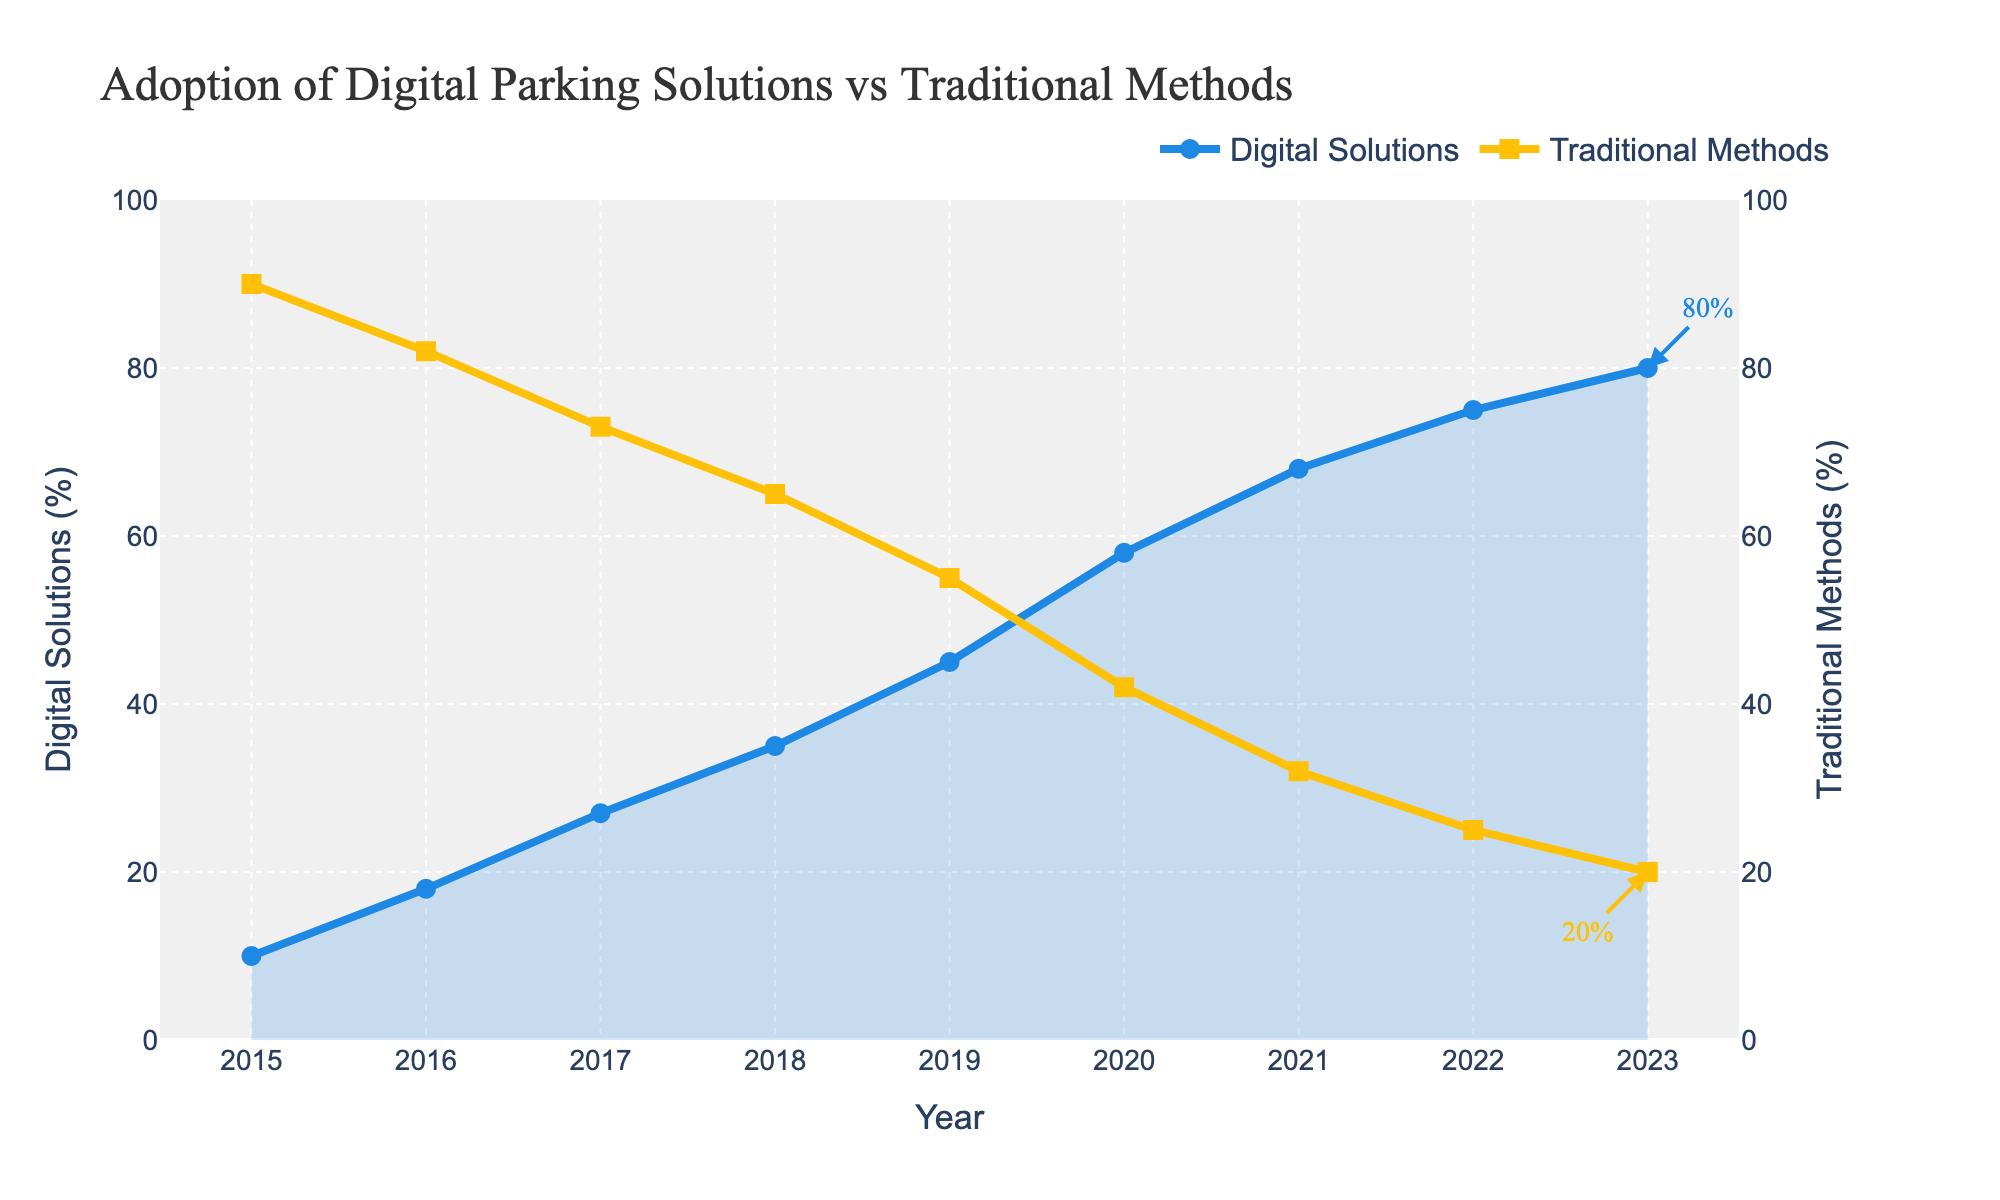What year did digital parking solutions first surpass traditional methods in adoption rate? In 2019, the usage percentage of digital parking solutions (45%) becomes higher than traditional methods (55%).
Answer: 2019 How much did the adoption of digital parking solutions grow from 2015 to 2023? In 2015, the adoption rate was 10%. By 2023, it reached 80%. So, the growth is 80% - 10% = 70%.
Answer: 70% What is the difference in the adoption rate of traditional methods between 2016 and 2022? In 2016, traditional methods had an adoption rate of 82%. By 2022, this rate dropped to 25%. The difference is 82% - 25% = 57%.
Answer: 57% By how much did the adoption rate of digital parking solutions increase between the year 2020 and 2021? In 2020, the adoption rate was 58%. In 2021, it was 68%. The increase is 68% - 58% = 10%.
Answer: 10% Which year showed the highest year-over-year increase in the adoption of digital parking solutions? Comparing year-over-year increases, the highest jump is between 2019 (45%) and 2020 (58%), which is 13%.
Answer: 2020 In which years did the adoption rate of traditional methods decrease by at least 10% from the previous year? From 2017 to 2018, it decreased from 73% to 65% (8%), not enough. From 2018 to 2019, it decreased from 65% to 55% (10%), from 2019 to 2020 it decreased from 55% to 42% (13%), and from 2020 to 2021 it decreased from 42% to 32% (10%). The years are 2019, 2020, and 2021.
Answer: 2019, 2020, 2021 What is the average adoption rate of digital parking solutions over the period from 2015 to 2023? Summing the values from 2015 to 2023 (10 + 18 + 27 + 35 + 45 + 58 + 68 + 75 + 80) gives 416. Dividing this by the number of years (9) results in an average of 416 / 9 ≈ 46.22%.
Answer: 46.22% What is the average annual decrease in the adoption rate of traditional methods from 2018 to 2023? The adoption rates from 2018 to 2023 are 65%, 55%, 42%, 32%, 25%, and 20%. The decrease each year is (65-55), (55-42), (42-32), (32-25), (25-20) giving 10, 13, 10, 7, 5. The total decrease is 45 over 5 years, so the average annual decrease is 45/5 = 9%.
Answer: 9% 